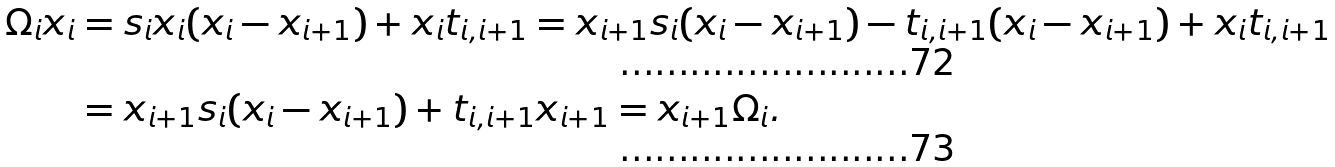Convert formula to latex. <formula><loc_0><loc_0><loc_500><loc_500>\Omega _ { i } x _ { i } & = s _ { i } x _ { i } ( x _ { i } - x _ { i + 1 } ) + x _ { i } t _ { i , i + 1 } = x _ { i + 1 } s _ { i } ( x _ { i } - x _ { i + 1 } ) - t _ { i , i + 1 } ( x _ { i } - x _ { i + 1 } ) + x _ { i } t _ { i , i + 1 } \\ & = x _ { i + 1 } s _ { i } ( x _ { i } - x _ { i + 1 } ) + t _ { i , i + 1 } x _ { i + 1 } = x _ { i + 1 } \Omega _ { i } .</formula> 